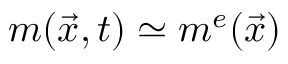<formula> <loc_0><loc_0><loc_500><loc_500>m ( \vec { x } , t ) \simeq m ^ { e } ( \vec { x } )</formula> 